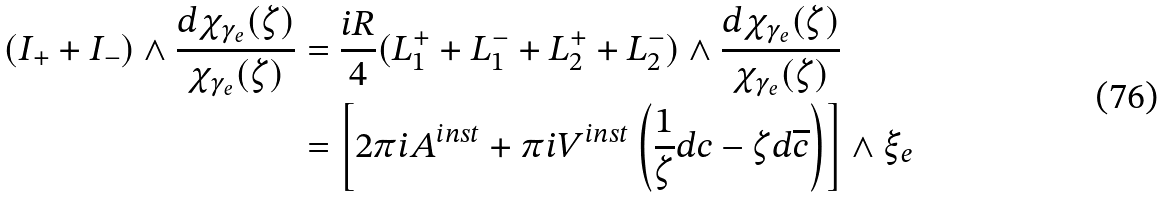Convert formula to latex. <formula><loc_0><loc_0><loc_500><loc_500>( I _ { + } + I _ { - } ) \wedge \frac { d \chi _ { \gamma _ { e } } ( \zeta ) } { \chi _ { \gamma _ { e } } ( \zeta ) } & = \frac { i R } { 4 } ( L ^ { + } _ { 1 } + L ^ { - } _ { 1 } + L ^ { + } _ { 2 } + L ^ { - } _ { 2 } ) \wedge \frac { d \chi _ { \gamma _ { e } } ( \zeta ) } { \chi _ { \gamma _ { e } } ( \zeta ) } \\ & = \left [ 2 \pi i A ^ { i n s t } + \pi i V ^ { i n s t } \left ( \frac { 1 } { \zeta } d c - \zeta d \overline { c } \right ) \right ] \wedge \xi _ { e }</formula> 